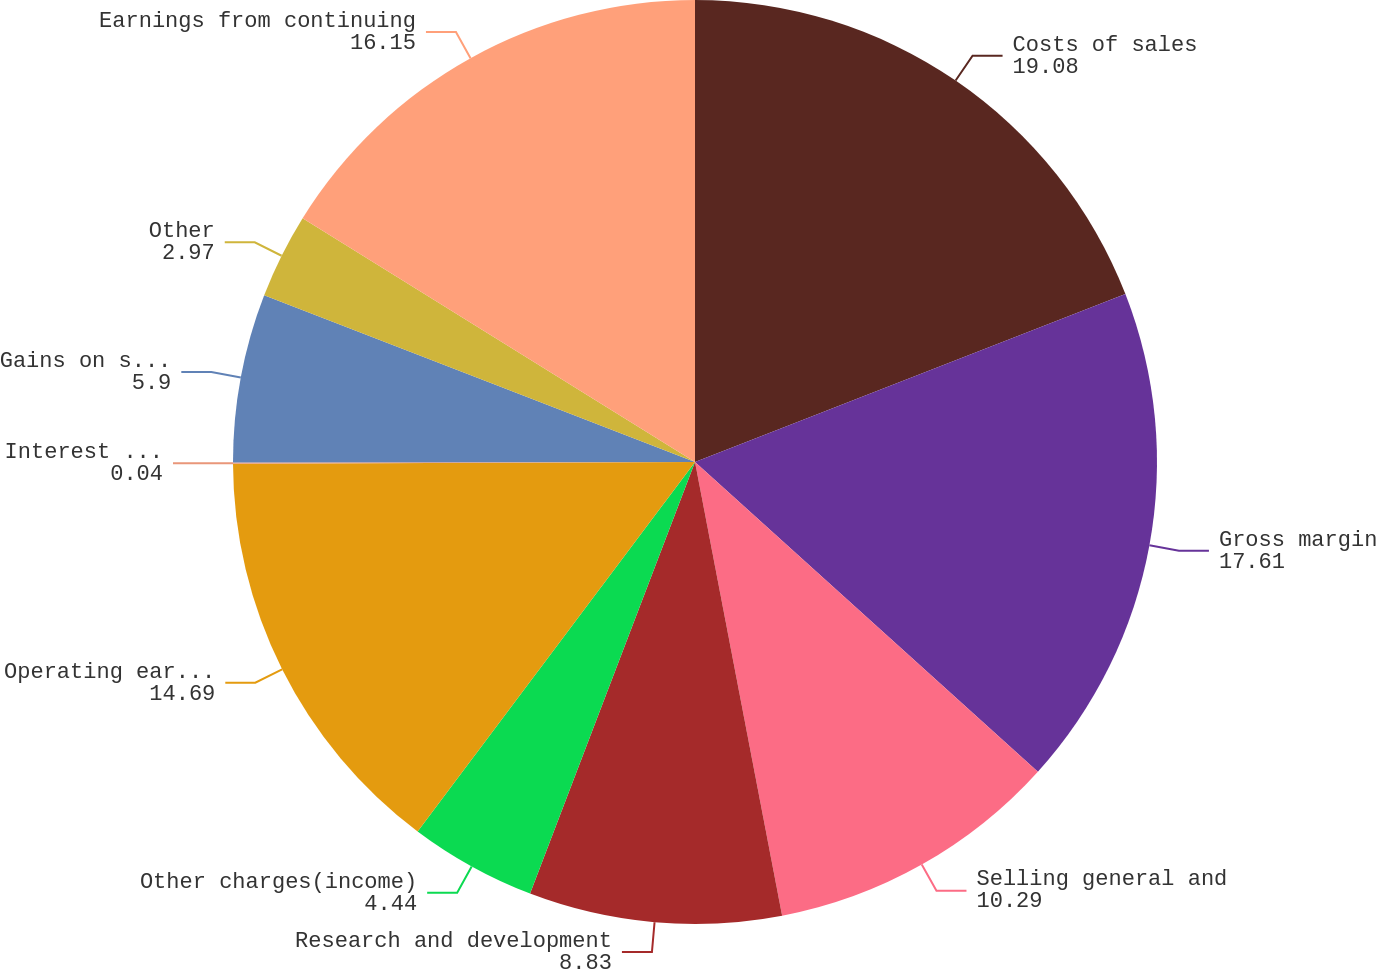Convert chart. <chart><loc_0><loc_0><loc_500><loc_500><pie_chart><fcel>Costs of sales<fcel>Gross margin<fcel>Selling general and<fcel>Research and development<fcel>Other charges(income)<fcel>Operating earnings<fcel>Interest income (expense) net<fcel>Gains on sales of investments<fcel>Other<fcel>Earnings from continuing<nl><fcel>19.08%<fcel>17.61%<fcel>10.29%<fcel>8.83%<fcel>4.44%<fcel>14.69%<fcel>0.04%<fcel>5.9%<fcel>2.97%<fcel>16.15%<nl></chart> 